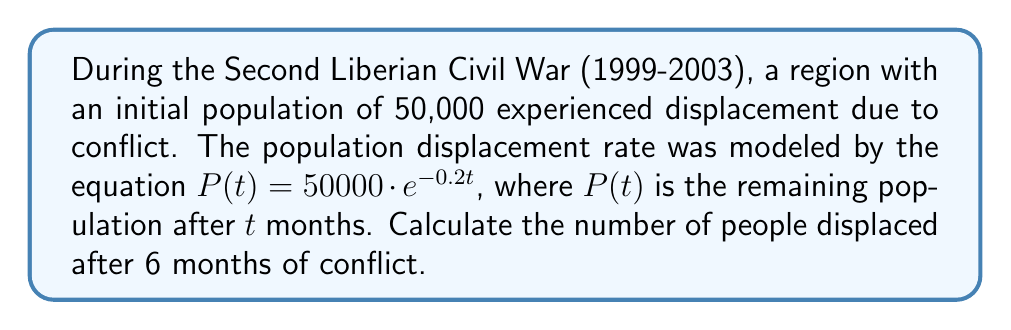Could you help me with this problem? To solve this problem, we'll follow these steps:

1) The initial population is 50,000.

2) The population displacement is modeled by the equation:
   $P(t) = 50000 \cdot e^{-0.2t}$

3) We need to find the population after 6 months, so we substitute $t = 6$ into the equation:
   $P(6) = 50000 \cdot e^{-0.2 \cdot 6}$

4) Simplify the exponent:
   $P(6) = 50000 \cdot e^{-1.2}$

5) Calculate $e^{-1.2}$ (you can use a calculator for this):
   $e^{-1.2} \approx 0.3012$

6) Multiply:
   $P(6) = 50000 \cdot 0.3012 \approx 15060$

7) This means that after 6 months, approximately 15,060 people remain in the region.

8) To find the number of people displaced, subtract the remaining population from the initial population:
   $50000 - 15060 = 34940$

Therefore, approximately 34,940 people were displaced after 6 months of conflict.
Answer: 34,940 people 